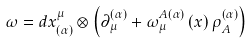Convert formula to latex. <formula><loc_0><loc_0><loc_500><loc_500>\omega = d x _ { \left ( \alpha \right ) } ^ { \mu } \otimes \left ( \partial _ { \mu } ^ { \left ( \alpha \right ) } + \omega _ { \mu } ^ { A \left ( \alpha \right ) } \left ( x \right ) \rho _ { A } ^ { \left ( \alpha \right ) } \right )</formula> 